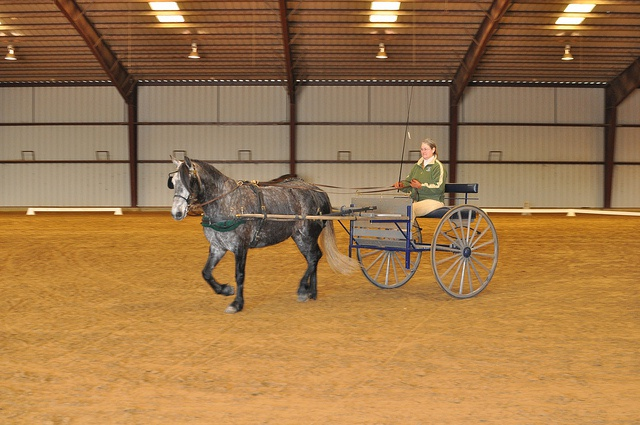Describe the objects in this image and their specific colors. I can see horse in maroon, gray, black, and tan tones and people in maroon, olive, and tan tones in this image. 